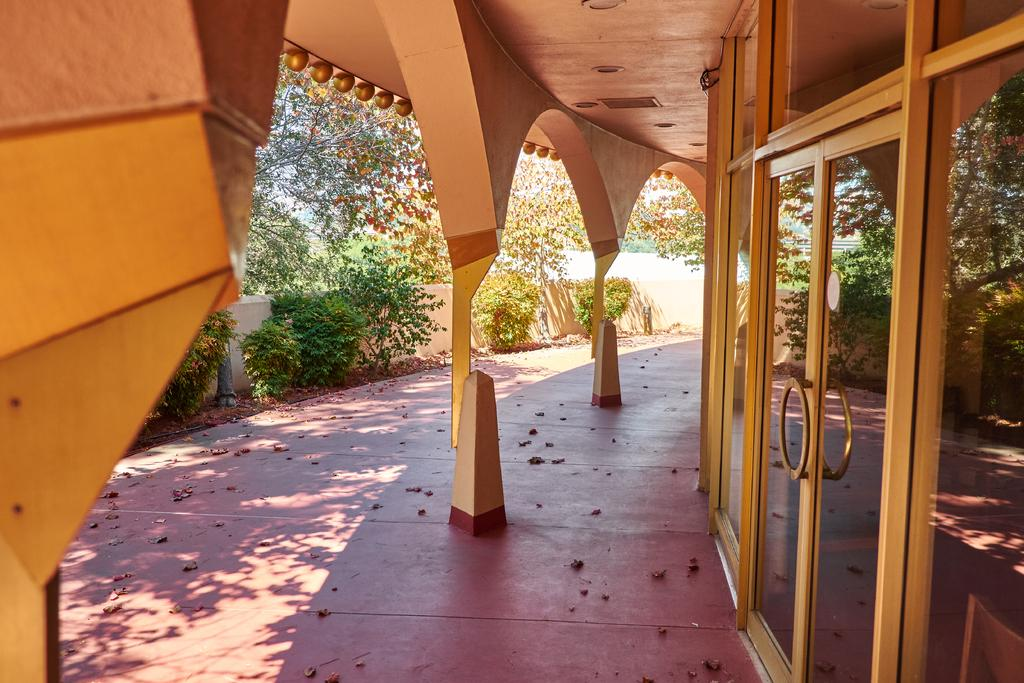What type of doors are visible in the image? There are glass doors in the image. What material are the pillars made of in the image? The pillars in the image are made of wood. What color are the trees in the image? The trees in the image have green leaves. What colors can be seen in the sky in the image? The sky in the image is blue and white in color. Where is the club located in the image? There is no club present in the image. What type of hook can be seen hanging from the trees in the image? There are no hooks present in the image; it features trees with green leaves. 